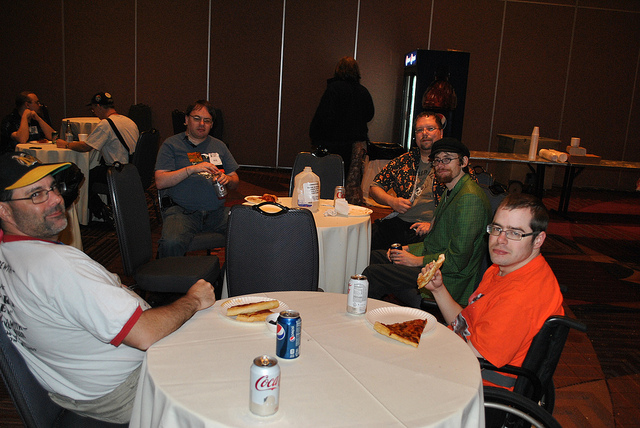Read all the text in this image. Coca 